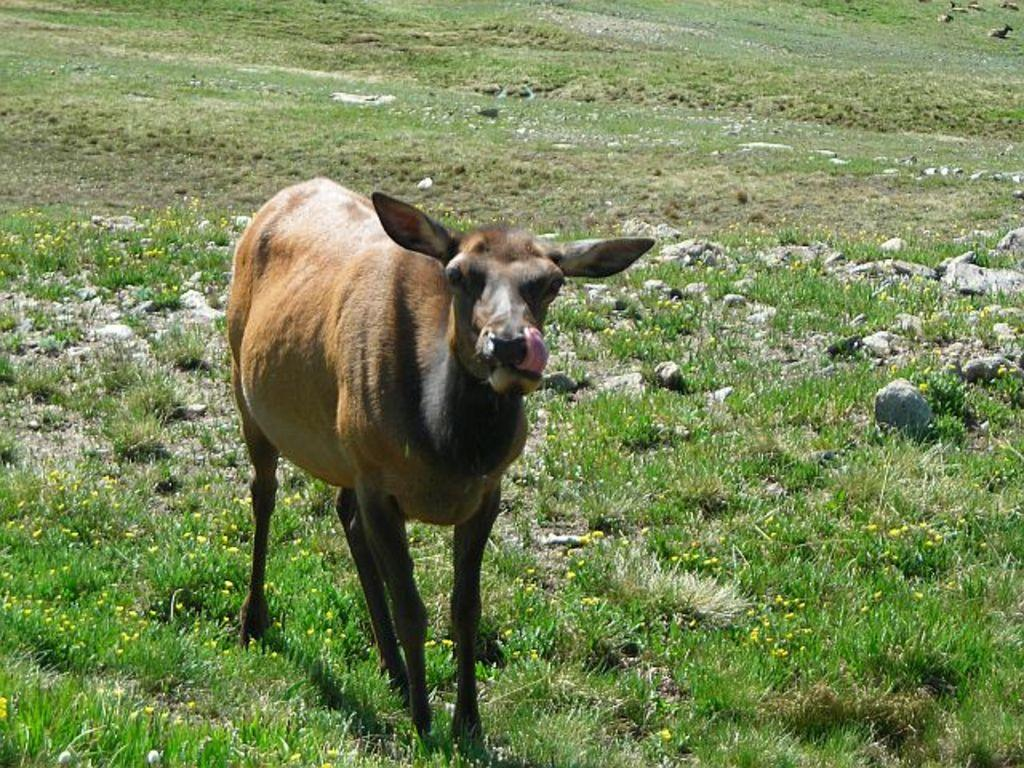What type of animal is in the foreground of the image? There is an animal in the foreground of the image, but the specific type cannot be determined from the provided facts. What is the environment surrounding the animal? The animal is surrounded by grass and small rocks. What type of wax is being used to create the airplane in the image? There is no airplane or wax present in the image; it features an animal surrounded by grass and small rocks. 